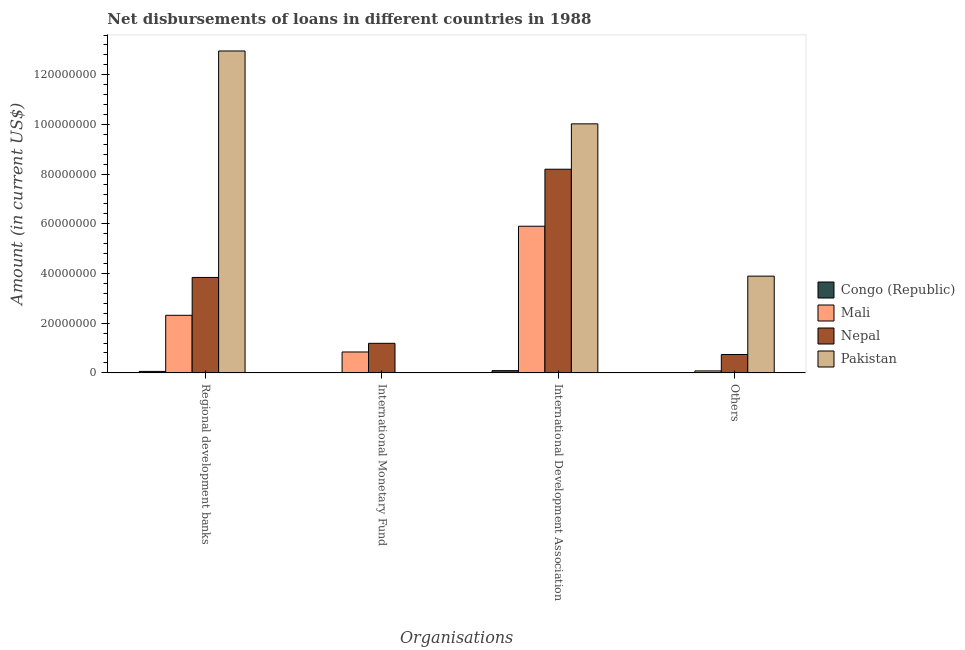How many groups of bars are there?
Your response must be concise. 4. Are the number of bars per tick equal to the number of legend labels?
Your answer should be very brief. No. Are the number of bars on each tick of the X-axis equal?
Make the answer very short. No. How many bars are there on the 3rd tick from the right?
Your response must be concise. 2. What is the label of the 2nd group of bars from the left?
Provide a succinct answer. International Monetary Fund. What is the amount of loan disimbursed by international development association in Congo (Republic)?
Ensure brevity in your answer.  8.98e+05. Across all countries, what is the maximum amount of loan disimbursed by international monetary fund?
Ensure brevity in your answer.  1.19e+07. Across all countries, what is the minimum amount of loan disimbursed by regional development banks?
Give a very brief answer. 5.84e+05. In which country was the amount of loan disimbursed by international monetary fund maximum?
Give a very brief answer. Nepal. What is the total amount of loan disimbursed by regional development banks in the graph?
Your answer should be compact. 1.92e+08. What is the difference between the amount of loan disimbursed by international monetary fund in Nepal and that in Mali?
Give a very brief answer. 3.49e+06. What is the difference between the amount of loan disimbursed by regional development banks in Nepal and the amount of loan disimbursed by international monetary fund in Pakistan?
Offer a very short reply. 3.84e+07. What is the average amount of loan disimbursed by other organisations per country?
Keep it short and to the point. 1.18e+07. What is the difference between the amount of loan disimbursed by other organisations and amount of loan disimbursed by international development association in Nepal?
Your answer should be very brief. -7.46e+07. What is the ratio of the amount of loan disimbursed by other organisations in Mali to that in Nepal?
Offer a very short reply. 0.11. Is the amount of loan disimbursed by international development association in Pakistan less than that in Nepal?
Ensure brevity in your answer.  No. Is the difference between the amount of loan disimbursed by international development association in Pakistan and Nepal greater than the difference between the amount of loan disimbursed by regional development banks in Pakistan and Nepal?
Offer a terse response. No. What is the difference between the highest and the second highest amount of loan disimbursed by international development association?
Your answer should be compact. 1.83e+07. What is the difference between the highest and the lowest amount of loan disimbursed by other organisations?
Make the answer very short. 3.89e+07. In how many countries, is the amount of loan disimbursed by international monetary fund greater than the average amount of loan disimbursed by international monetary fund taken over all countries?
Provide a succinct answer. 2. Is it the case that in every country, the sum of the amount of loan disimbursed by regional development banks and amount of loan disimbursed by international monetary fund is greater than the amount of loan disimbursed by international development association?
Offer a terse response. No. How many bars are there?
Offer a terse response. 13. How many countries are there in the graph?
Provide a succinct answer. 4. Are the values on the major ticks of Y-axis written in scientific E-notation?
Keep it short and to the point. No. Does the graph contain any zero values?
Your response must be concise. Yes. Does the graph contain grids?
Your answer should be very brief. No. Where does the legend appear in the graph?
Keep it short and to the point. Center right. How many legend labels are there?
Your answer should be very brief. 4. What is the title of the graph?
Make the answer very short. Net disbursements of loans in different countries in 1988. Does "Samoa" appear as one of the legend labels in the graph?
Offer a terse response. No. What is the label or title of the X-axis?
Your answer should be very brief. Organisations. What is the Amount (in current US$) in Congo (Republic) in Regional development banks?
Give a very brief answer. 5.84e+05. What is the Amount (in current US$) of Mali in Regional development banks?
Make the answer very short. 2.32e+07. What is the Amount (in current US$) of Nepal in Regional development banks?
Provide a short and direct response. 3.84e+07. What is the Amount (in current US$) in Pakistan in Regional development banks?
Your response must be concise. 1.30e+08. What is the Amount (in current US$) in Mali in International Monetary Fund?
Offer a terse response. 8.41e+06. What is the Amount (in current US$) of Nepal in International Monetary Fund?
Keep it short and to the point. 1.19e+07. What is the Amount (in current US$) in Pakistan in International Monetary Fund?
Give a very brief answer. 0. What is the Amount (in current US$) of Congo (Republic) in International Development Association?
Ensure brevity in your answer.  8.98e+05. What is the Amount (in current US$) of Mali in International Development Association?
Your response must be concise. 5.90e+07. What is the Amount (in current US$) of Nepal in International Development Association?
Provide a succinct answer. 8.20e+07. What is the Amount (in current US$) of Pakistan in International Development Association?
Your response must be concise. 1.00e+08. What is the Amount (in current US$) in Mali in Others?
Ensure brevity in your answer.  7.87e+05. What is the Amount (in current US$) of Nepal in Others?
Offer a very short reply. 7.39e+06. What is the Amount (in current US$) in Pakistan in Others?
Keep it short and to the point. 3.89e+07. Across all Organisations, what is the maximum Amount (in current US$) of Congo (Republic)?
Your answer should be very brief. 8.98e+05. Across all Organisations, what is the maximum Amount (in current US$) in Mali?
Your answer should be compact. 5.90e+07. Across all Organisations, what is the maximum Amount (in current US$) in Nepal?
Ensure brevity in your answer.  8.20e+07. Across all Organisations, what is the maximum Amount (in current US$) in Pakistan?
Give a very brief answer. 1.30e+08. Across all Organisations, what is the minimum Amount (in current US$) in Mali?
Your answer should be compact. 7.87e+05. Across all Organisations, what is the minimum Amount (in current US$) of Nepal?
Ensure brevity in your answer.  7.39e+06. Across all Organisations, what is the minimum Amount (in current US$) in Pakistan?
Your answer should be compact. 0. What is the total Amount (in current US$) of Congo (Republic) in the graph?
Ensure brevity in your answer.  1.48e+06. What is the total Amount (in current US$) in Mali in the graph?
Provide a succinct answer. 9.14e+07. What is the total Amount (in current US$) of Nepal in the graph?
Provide a succinct answer. 1.40e+08. What is the total Amount (in current US$) of Pakistan in the graph?
Your answer should be compact. 2.69e+08. What is the difference between the Amount (in current US$) in Mali in Regional development banks and that in International Monetary Fund?
Offer a very short reply. 1.48e+07. What is the difference between the Amount (in current US$) of Nepal in Regional development banks and that in International Monetary Fund?
Provide a succinct answer. 2.65e+07. What is the difference between the Amount (in current US$) in Congo (Republic) in Regional development banks and that in International Development Association?
Offer a terse response. -3.14e+05. What is the difference between the Amount (in current US$) of Mali in Regional development banks and that in International Development Association?
Your answer should be compact. -3.59e+07. What is the difference between the Amount (in current US$) in Nepal in Regional development banks and that in International Development Association?
Your answer should be compact. -4.36e+07. What is the difference between the Amount (in current US$) of Pakistan in Regional development banks and that in International Development Association?
Ensure brevity in your answer.  2.93e+07. What is the difference between the Amount (in current US$) in Mali in Regional development banks and that in Others?
Offer a very short reply. 2.24e+07. What is the difference between the Amount (in current US$) in Nepal in Regional development banks and that in Others?
Ensure brevity in your answer.  3.10e+07. What is the difference between the Amount (in current US$) of Pakistan in Regional development banks and that in Others?
Keep it short and to the point. 9.06e+07. What is the difference between the Amount (in current US$) of Mali in International Monetary Fund and that in International Development Association?
Your answer should be very brief. -5.06e+07. What is the difference between the Amount (in current US$) of Nepal in International Monetary Fund and that in International Development Association?
Ensure brevity in your answer.  -7.01e+07. What is the difference between the Amount (in current US$) in Mali in International Monetary Fund and that in Others?
Offer a very short reply. 7.62e+06. What is the difference between the Amount (in current US$) in Nepal in International Monetary Fund and that in Others?
Your answer should be compact. 4.51e+06. What is the difference between the Amount (in current US$) in Mali in International Development Association and that in Others?
Keep it short and to the point. 5.82e+07. What is the difference between the Amount (in current US$) of Nepal in International Development Association and that in Others?
Offer a very short reply. 7.46e+07. What is the difference between the Amount (in current US$) in Pakistan in International Development Association and that in Others?
Offer a very short reply. 6.13e+07. What is the difference between the Amount (in current US$) of Congo (Republic) in Regional development banks and the Amount (in current US$) of Mali in International Monetary Fund?
Offer a very short reply. -7.82e+06. What is the difference between the Amount (in current US$) of Congo (Republic) in Regional development banks and the Amount (in current US$) of Nepal in International Monetary Fund?
Ensure brevity in your answer.  -1.13e+07. What is the difference between the Amount (in current US$) of Mali in Regional development banks and the Amount (in current US$) of Nepal in International Monetary Fund?
Provide a succinct answer. 1.13e+07. What is the difference between the Amount (in current US$) in Congo (Republic) in Regional development banks and the Amount (in current US$) in Mali in International Development Association?
Provide a succinct answer. -5.84e+07. What is the difference between the Amount (in current US$) of Congo (Republic) in Regional development banks and the Amount (in current US$) of Nepal in International Development Association?
Offer a terse response. -8.14e+07. What is the difference between the Amount (in current US$) of Congo (Republic) in Regional development banks and the Amount (in current US$) of Pakistan in International Development Association?
Offer a very short reply. -9.97e+07. What is the difference between the Amount (in current US$) of Mali in Regional development banks and the Amount (in current US$) of Nepal in International Development Association?
Your response must be concise. -5.88e+07. What is the difference between the Amount (in current US$) of Mali in Regional development banks and the Amount (in current US$) of Pakistan in International Development Association?
Offer a very short reply. -7.71e+07. What is the difference between the Amount (in current US$) in Nepal in Regional development banks and the Amount (in current US$) in Pakistan in International Development Association?
Offer a terse response. -6.18e+07. What is the difference between the Amount (in current US$) in Congo (Republic) in Regional development banks and the Amount (in current US$) in Mali in Others?
Offer a terse response. -2.03e+05. What is the difference between the Amount (in current US$) of Congo (Republic) in Regional development banks and the Amount (in current US$) of Nepal in Others?
Your response must be concise. -6.80e+06. What is the difference between the Amount (in current US$) of Congo (Republic) in Regional development banks and the Amount (in current US$) of Pakistan in Others?
Keep it short and to the point. -3.84e+07. What is the difference between the Amount (in current US$) in Mali in Regional development banks and the Amount (in current US$) in Nepal in Others?
Give a very brief answer. 1.58e+07. What is the difference between the Amount (in current US$) in Mali in Regional development banks and the Amount (in current US$) in Pakistan in Others?
Provide a succinct answer. -1.58e+07. What is the difference between the Amount (in current US$) of Nepal in Regional development banks and the Amount (in current US$) of Pakistan in Others?
Offer a very short reply. -5.29e+05. What is the difference between the Amount (in current US$) in Mali in International Monetary Fund and the Amount (in current US$) in Nepal in International Development Association?
Keep it short and to the point. -7.36e+07. What is the difference between the Amount (in current US$) in Mali in International Monetary Fund and the Amount (in current US$) in Pakistan in International Development Association?
Your answer should be very brief. -9.18e+07. What is the difference between the Amount (in current US$) of Nepal in International Monetary Fund and the Amount (in current US$) of Pakistan in International Development Association?
Provide a succinct answer. -8.83e+07. What is the difference between the Amount (in current US$) of Mali in International Monetary Fund and the Amount (in current US$) of Nepal in Others?
Your response must be concise. 1.02e+06. What is the difference between the Amount (in current US$) of Mali in International Monetary Fund and the Amount (in current US$) of Pakistan in Others?
Provide a succinct answer. -3.05e+07. What is the difference between the Amount (in current US$) in Nepal in International Monetary Fund and the Amount (in current US$) in Pakistan in Others?
Your response must be concise. -2.70e+07. What is the difference between the Amount (in current US$) of Congo (Republic) in International Development Association and the Amount (in current US$) of Mali in Others?
Keep it short and to the point. 1.11e+05. What is the difference between the Amount (in current US$) of Congo (Republic) in International Development Association and the Amount (in current US$) of Nepal in Others?
Offer a very short reply. -6.49e+06. What is the difference between the Amount (in current US$) in Congo (Republic) in International Development Association and the Amount (in current US$) in Pakistan in Others?
Offer a terse response. -3.80e+07. What is the difference between the Amount (in current US$) in Mali in International Development Association and the Amount (in current US$) in Nepal in Others?
Provide a short and direct response. 5.16e+07. What is the difference between the Amount (in current US$) of Mali in International Development Association and the Amount (in current US$) of Pakistan in Others?
Ensure brevity in your answer.  2.01e+07. What is the difference between the Amount (in current US$) in Nepal in International Development Association and the Amount (in current US$) in Pakistan in Others?
Keep it short and to the point. 4.30e+07. What is the average Amount (in current US$) of Congo (Republic) per Organisations?
Offer a very short reply. 3.70e+05. What is the average Amount (in current US$) in Mali per Organisations?
Provide a succinct answer. 2.28e+07. What is the average Amount (in current US$) of Nepal per Organisations?
Give a very brief answer. 3.49e+07. What is the average Amount (in current US$) of Pakistan per Organisations?
Offer a terse response. 6.72e+07. What is the difference between the Amount (in current US$) of Congo (Republic) and Amount (in current US$) of Mali in Regional development banks?
Make the answer very short. -2.26e+07. What is the difference between the Amount (in current US$) in Congo (Republic) and Amount (in current US$) in Nepal in Regional development banks?
Your response must be concise. -3.78e+07. What is the difference between the Amount (in current US$) of Congo (Republic) and Amount (in current US$) of Pakistan in Regional development banks?
Make the answer very short. -1.29e+08. What is the difference between the Amount (in current US$) of Mali and Amount (in current US$) of Nepal in Regional development banks?
Offer a terse response. -1.52e+07. What is the difference between the Amount (in current US$) in Mali and Amount (in current US$) in Pakistan in Regional development banks?
Your answer should be very brief. -1.06e+08. What is the difference between the Amount (in current US$) in Nepal and Amount (in current US$) in Pakistan in Regional development banks?
Provide a short and direct response. -9.12e+07. What is the difference between the Amount (in current US$) of Mali and Amount (in current US$) of Nepal in International Monetary Fund?
Offer a terse response. -3.49e+06. What is the difference between the Amount (in current US$) of Congo (Republic) and Amount (in current US$) of Mali in International Development Association?
Your answer should be compact. -5.81e+07. What is the difference between the Amount (in current US$) of Congo (Republic) and Amount (in current US$) of Nepal in International Development Association?
Keep it short and to the point. -8.11e+07. What is the difference between the Amount (in current US$) in Congo (Republic) and Amount (in current US$) in Pakistan in International Development Association?
Your response must be concise. -9.93e+07. What is the difference between the Amount (in current US$) in Mali and Amount (in current US$) in Nepal in International Development Association?
Make the answer very short. -2.29e+07. What is the difference between the Amount (in current US$) of Mali and Amount (in current US$) of Pakistan in International Development Association?
Your response must be concise. -4.12e+07. What is the difference between the Amount (in current US$) of Nepal and Amount (in current US$) of Pakistan in International Development Association?
Offer a very short reply. -1.83e+07. What is the difference between the Amount (in current US$) of Mali and Amount (in current US$) of Nepal in Others?
Provide a succinct answer. -6.60e+06. What is the difference between the Amount (in current US$) of Mali and Amount (in current US$) of Pakistan in Others?
Provide a succinct answer. -3.82e+07. What is the difference between the Amount (in current US$) of Nepal and Amount (in current US$) of Pakistan in Others?
Your answer should be very brief. -3.16e+07. What is the ratio of the Amount (in current US$) of Mali in Regional development banks to that in International Monetary Fund?
Ensure brevity in your answer.  2.76. What is the ratio of the Amount (in current US$) of Nepal in Regional development banks to that in International Monetary Fund?
Provide a succinct answer. 3.23. What is the ratio of the Amount (in current US$) of Congo (Republic) in Regional development banks to that in International Development Association?
Your answer should be compact. 0.65. What is the ratio of the Amount (in current US$) in Mali in Regional development banks to that in International Development Association?
Your answer should be compact. 0.39. What is the ratio of the Amount (in current US$) of Nepal in Regional development banks to that in International Development Association?
Give a very brief answer. 0.47. What is the ratio of the Amount (in current US$) in Pakistan in Regional development banks to that in International Development Association?
Give a very brief answer. 1.29. What is the ratio of the Amount (in current US$) in Mali in Regional development banks to that in Others?
Give a very brief answer. 29.44. What is the ratio of the Amount (in current US$) of Nepal in Regional development banks to that in Others?
Provide a succinct answer. 5.2. What is the ratio of the Amount (in current US$) of Pakistan in Regional development banks to that in Others?
Your answer should be very brief. 3.33. What is the ratio of the Amount (in current US$) in Mali in International Monetary Fund to that in International Development Association?
Your answer should be very brief. 0.14. What is the ratio of the Amount (in current US$) of Nepal in International Monetary Fund to that in International Development Association?
Give a very brief answer. 0.15. What is the ratio of the Amount (in current US$) in Mali in International Monetary Fund to that in Others?
Your response must be concise. 10.68. What is the ratio of the Amount (in current US$) of Nepal in International Monetary Fund to that in Others?
Your answer should be compact. 1.61. What is the ratio of the Amount (in current US$) in Mali in International Development Association to that in Others?
Offer a terse response. 75. What is the ratio of the Amount (in current US$) in Nepal in International Development Association to that in Others?
Keep it short and to the point. 11.1. What is the ratio of the Amount (in current US$) of Pakistan in International Development Association to that in Others?
Ensure brevity in your answer.  2.57. What is the difference between the highest and the second highest Amount (in current US$) of Mali?
Make the answer very short. 3.59e+07. What is the difference between the highest and the second highest Amount (in current US$) of Nepal?
Your response must be concise. 4.36e+07. What is the difference between the highest and the second highest Amount (in current US$) in Pakistan?
Your answer should be compact. 2.93e+07. What is the difference between the highest and the lowest Amount (in current US$) of Congo (Republic)?
Provide a short and direct response. 8.98e+05. What is the difference between the highest and the lowest Amount (in current US$) in Mali?
Provide a short and direct response. 5.82e+07. What is the difference between the highest and the lowest Amount (in current US$) in Nepal?
Keep it short and to the point. 7.46e+07. What is the difference between the highest and the lowest Amount (in current US$) in Pakistan?
Make the answer very short. 1.30e+08. 